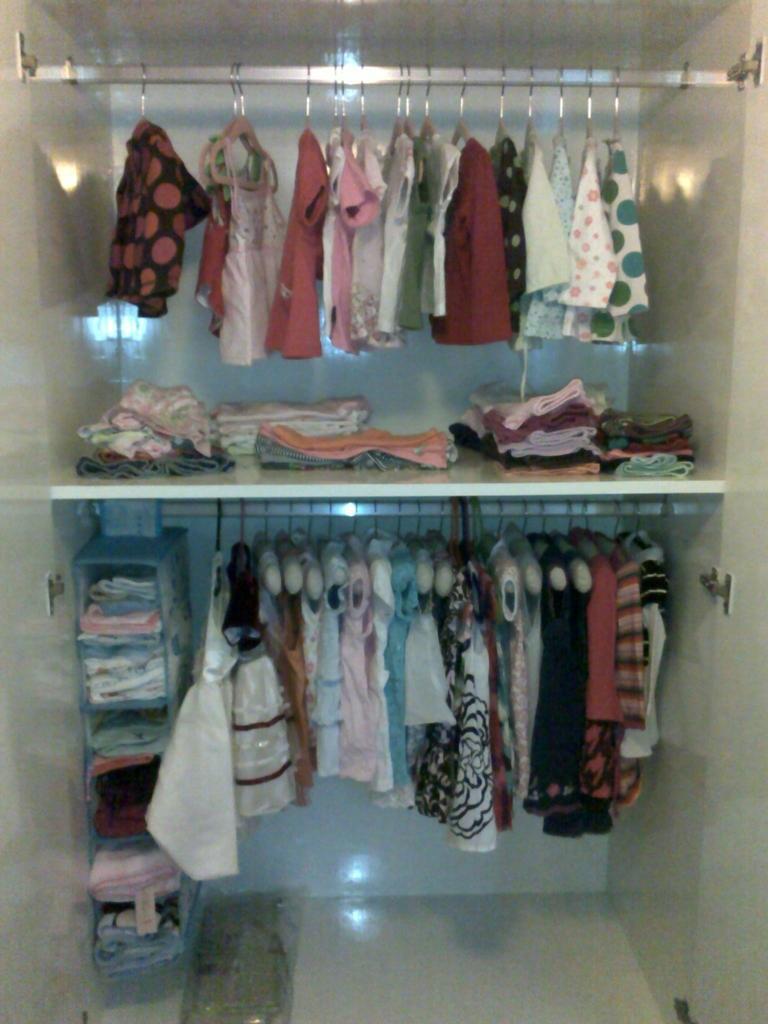Can you describe this image briefly? In this picture, we see many clothes are hanged to the hangers. We even see clothes placed in the rack. This might be a cupboard. This picture might be clicked in the room. 